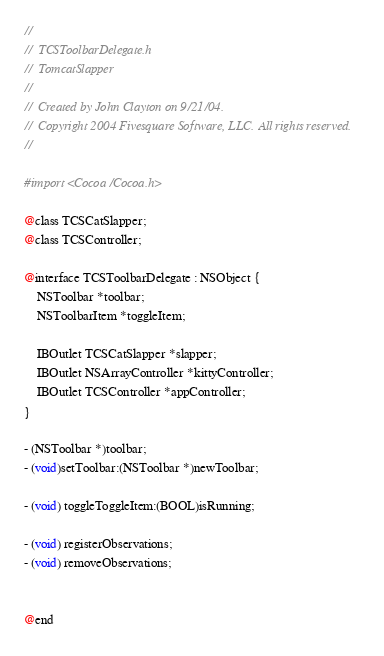Convert code to text. <code><loc_0><loc_0><loc_500><loc_500><_C_>//
//  TCSToolbarDelegate.h
//  TomcatSlapper
//
//  Created by John Clayton on 9/21/04.
//  Copyright 2004 Fivesquare Software, LLC. All rights reserved.
//

#import <Cocoa/Cocoa.h>

@class TCSCatSlapper;
@class TCSController;

@interface TCSToolbarDelegate : NSObject {
    NSToolbar *toolbar;
    NSToolbarItem *toggleItem;
    
    IBOutlet TCSCatSlapper *slapper;
    IBOutlet NSArrayController *kittyController;
    IBOutlet TCSController *appController;
}

- (NSToolbar *)toolbar;
- (void)setToolbar:(NSToolbar *)newToolbar;

- (void) toggleToggleItem:(BOOL)isRunning;

- (void) registerObservations;
- (void) removeObservations;


@end
</code> 